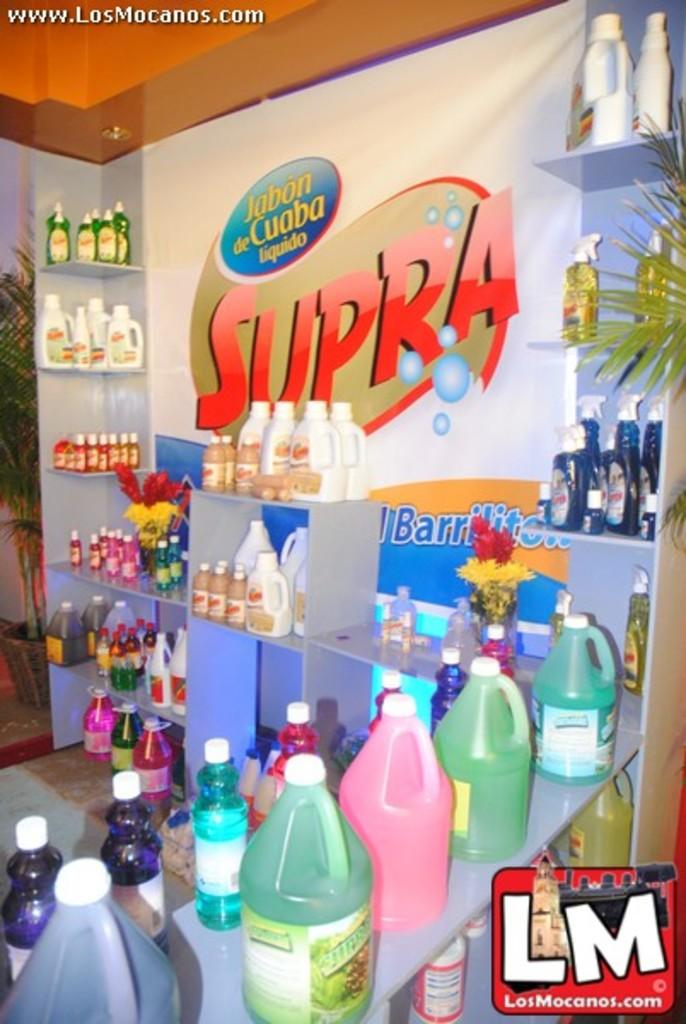Provide a one-sentence caption for the provided image. A colorful display of Supra products depicts various colors and containers, is in full view. 